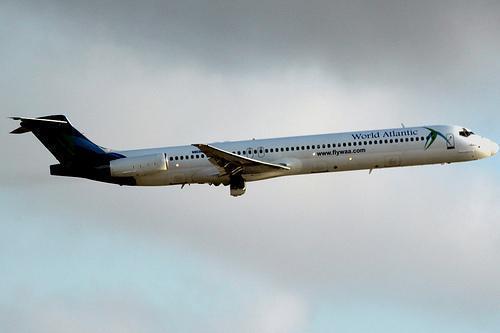How many planes in the photo?
Give a very brief answer. 1. 